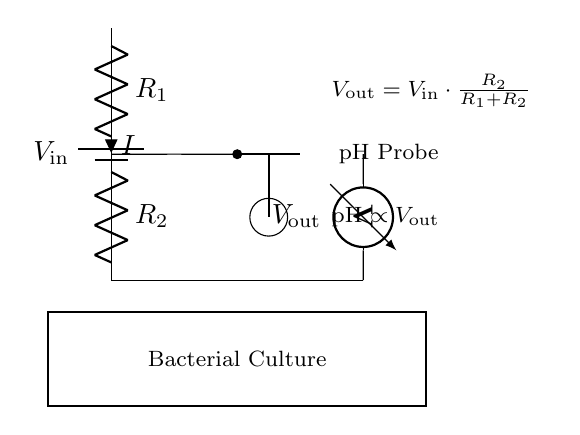What components are present in the circuit? The circuit contains a battery, two resistors (R1 and R2), a pH probe, and a voltmeter.
Answer: Battery, R1, R2, pH Probe, Voltmeter What is the purpose of the pH probe in this circuit? The pH probe is used to measure the pH level of the bacterial culture, as indicated by the connection to the voltage divider.
Answer: Measure pH What formula is represented in the diagram for the output voltage? The formula shown in the circuit is Vout = Vin * (R2 / (R1 + R2)), which defines how the output voltage is derived from the input voltage and the resistances.
Answer: Vout = Vin * (R2 / (R1 + R2)) What is the relationship between pH and Vout indicated in the circuit? The diagram states that pH is proportional to Vout, meaning as the voltage output changes, the pH measurement reflects that change accordingly.
Answer: pH ∝ Vout What is the total current flowing through the circuit if Vout is measured? The current I through the resistors can be calculated using Ohm's law and is given by I = Vin / (R1 + R2); this means knowing Vin and the resistor values can determine I.
Answer: I = Vin / (R1 + R2) Why is a voltage divider circuit used for pH measurement instead of a direct connection? A voltage divider circuit allows for accurate scaling of the voltage output proportional to the pH level, rather than applying the full sensor output directly, which can protect sensitive measuring devices like voltmeters.
Answer: For accurate scaling 